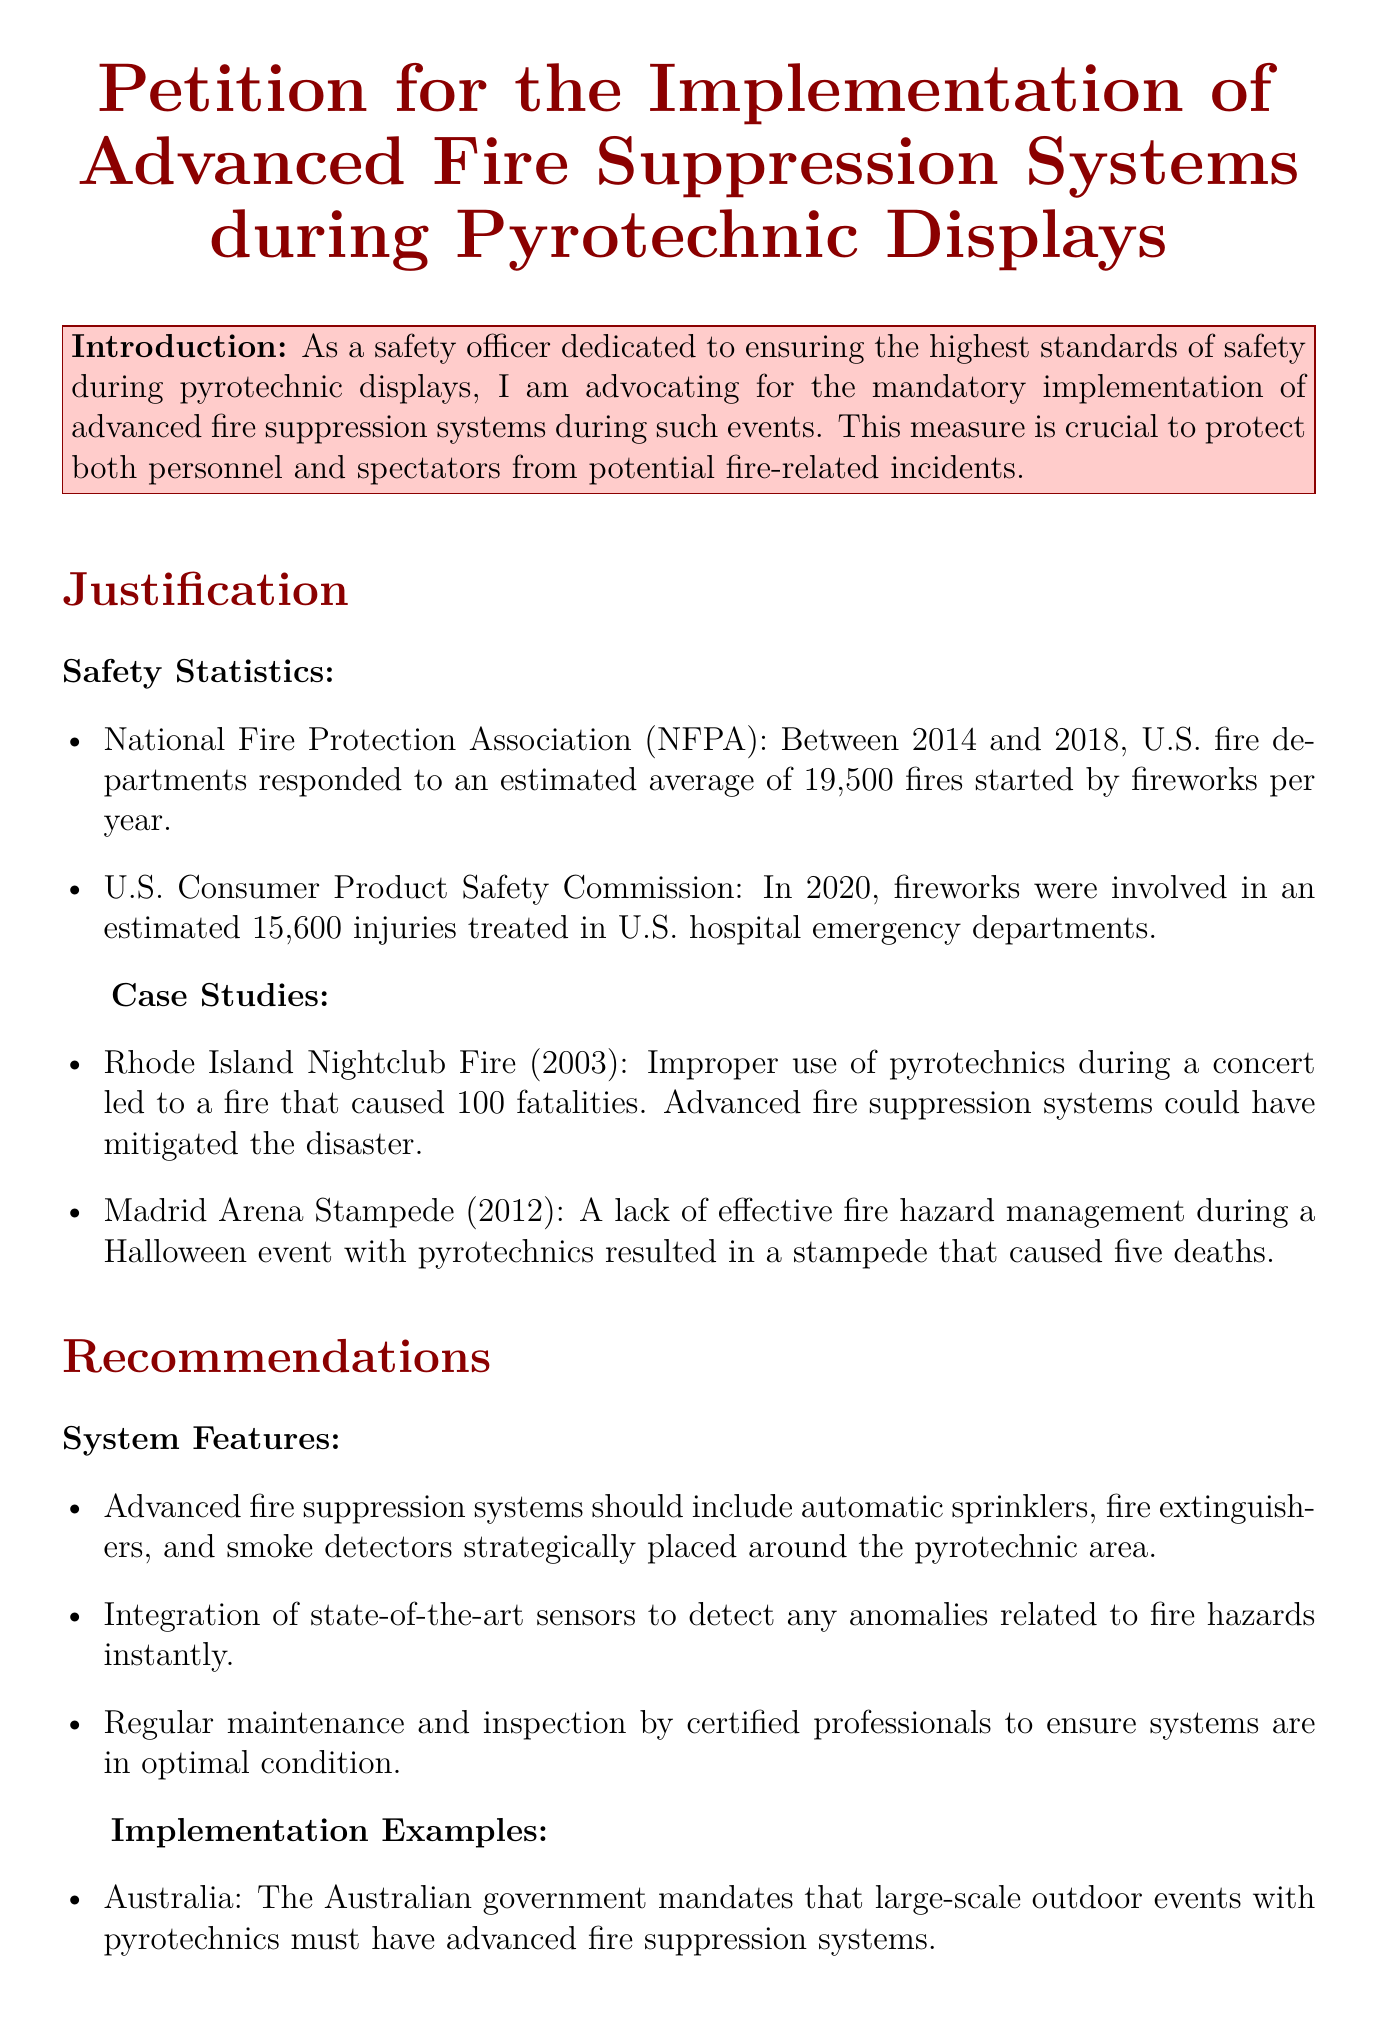What is the average number of fires started by fireworks per year according to the NFPA? The document states that U.S. fire departments responded to an estimated average of 19,500 fires started by fireworks per year between 2014 and 2018.
Answer: 19,500 In what year were there an estimated 15,600 fireworks-related injuries? According to the U.S. Consumer Product Safety Commission, fireworks were involved in an estimated 15,600 injuries in 2020.
Answer: 2020 What tragic event occurred due to improper use of pyrotechnics in 2003? The document mentions the Rhode Island Nightclub Fire in 2003, which resulted in 100 fatalities due to improper use of pyrotechnics.
Answer: Rhode Island Nightclub Fire What are two features recommended for advanced fire suppression systems? The document lists two features: automatic sprinklers and smoke detectors strategically placed around the pyrotechnic area.
Answer: Automatic sprinklers and smoke detectors Which country mandates advanced fire suppression systems for large-scale outdoor events? The document states that Australia mandates these systems for large-scale outdoor events with pyrotechnics.
Answer: Australia What is essential for maintaining the fire suppression systems? The petition emphasizes the importance of regular maintenance and inspection by certified professionals to ensure systems are in optimal condition.
Answer: Regular maintenance and inspection What is the central purpose of this petition? The conclusion of the document states that the central purpose is to support a critical safety initiative that aims to prevent fire-related accidents.
Answer: Prevent fire-related accidents What is the title of this document? The title of the document clearly states it is a petition for the implementation of advanced fire suppression systems during pyrotechnic displays.
Answer: Petition for the Implementation of Advanced Fire Suppression Systems during Pyrotechnic Displays 